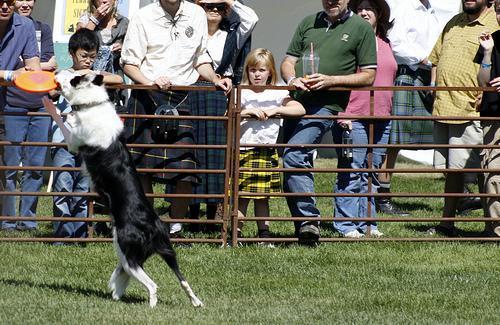How many frisbees?
Give a very brief answer. 1. How many dogs?
Give a very brief answer. 1. 